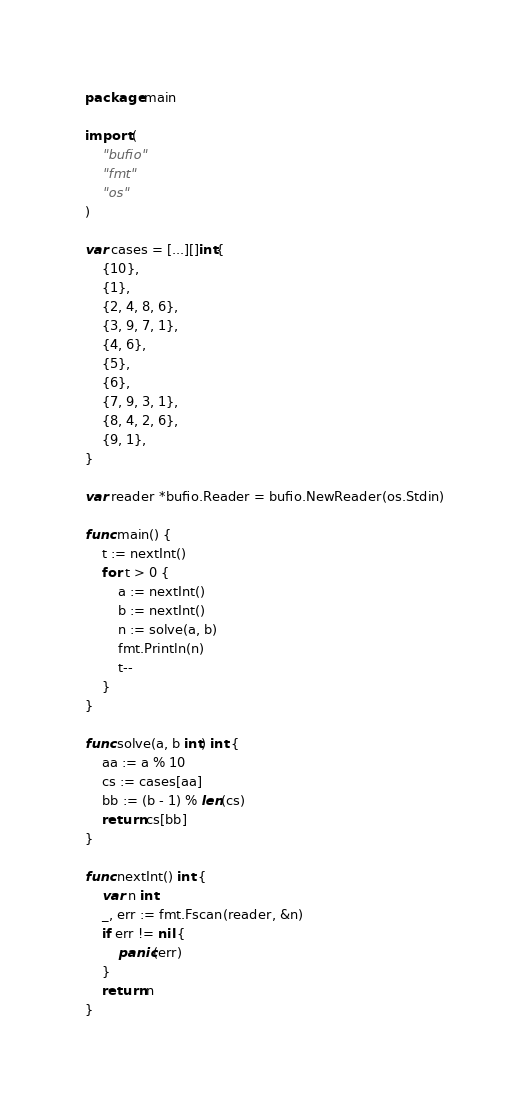Convert code to text. <code><loc_0><loc_0><loc_500><loc_500><_Go_>package main

import (
	"bufio"
	"fmt"
	"os"
)

var cases = [...][]int{
	{10},
	{1},
	{2, 4, 8, 6},
	{3, 9, 7, 1},
	{4, 6},
	{5},
	{6},
	{7, 9, 3, 1},
	{8, 4, 2, 6},
	{9, 1},
}

var reader *bufio.Reader = bufio.NewReader(os.Stdin)

func main() {
	t := nextInt()
	for t > 0 {
		a := nextInt()
		b := nextInt()
		n := solve(a, b)
		fmt.Println(n)
		t--
	}
}

func solve(a, b int) int {
	aa := a % 10
	cs := cases[aa]
	bb := (b - 1) % len(cs)
	return cs[bb]
}

func nextInt() int {
	var n int
	_, err := fmt.Fscan(reader, &n)
	if err != nil {
		panic(err)
	}
	return n
}
</code> 